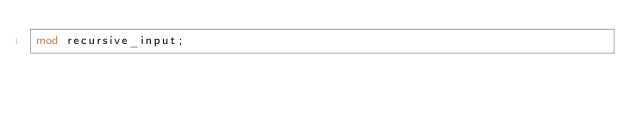<code> <loc_0><loc_0><loc_500><loc_500><_Rust_>mod recursive_input;
</code> 